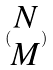Convert formula to latex. <formula><loc_0><loc_0><loc_500><loc_500>( \begin{matrix} N \\ M \end{matrix} )</formula> 